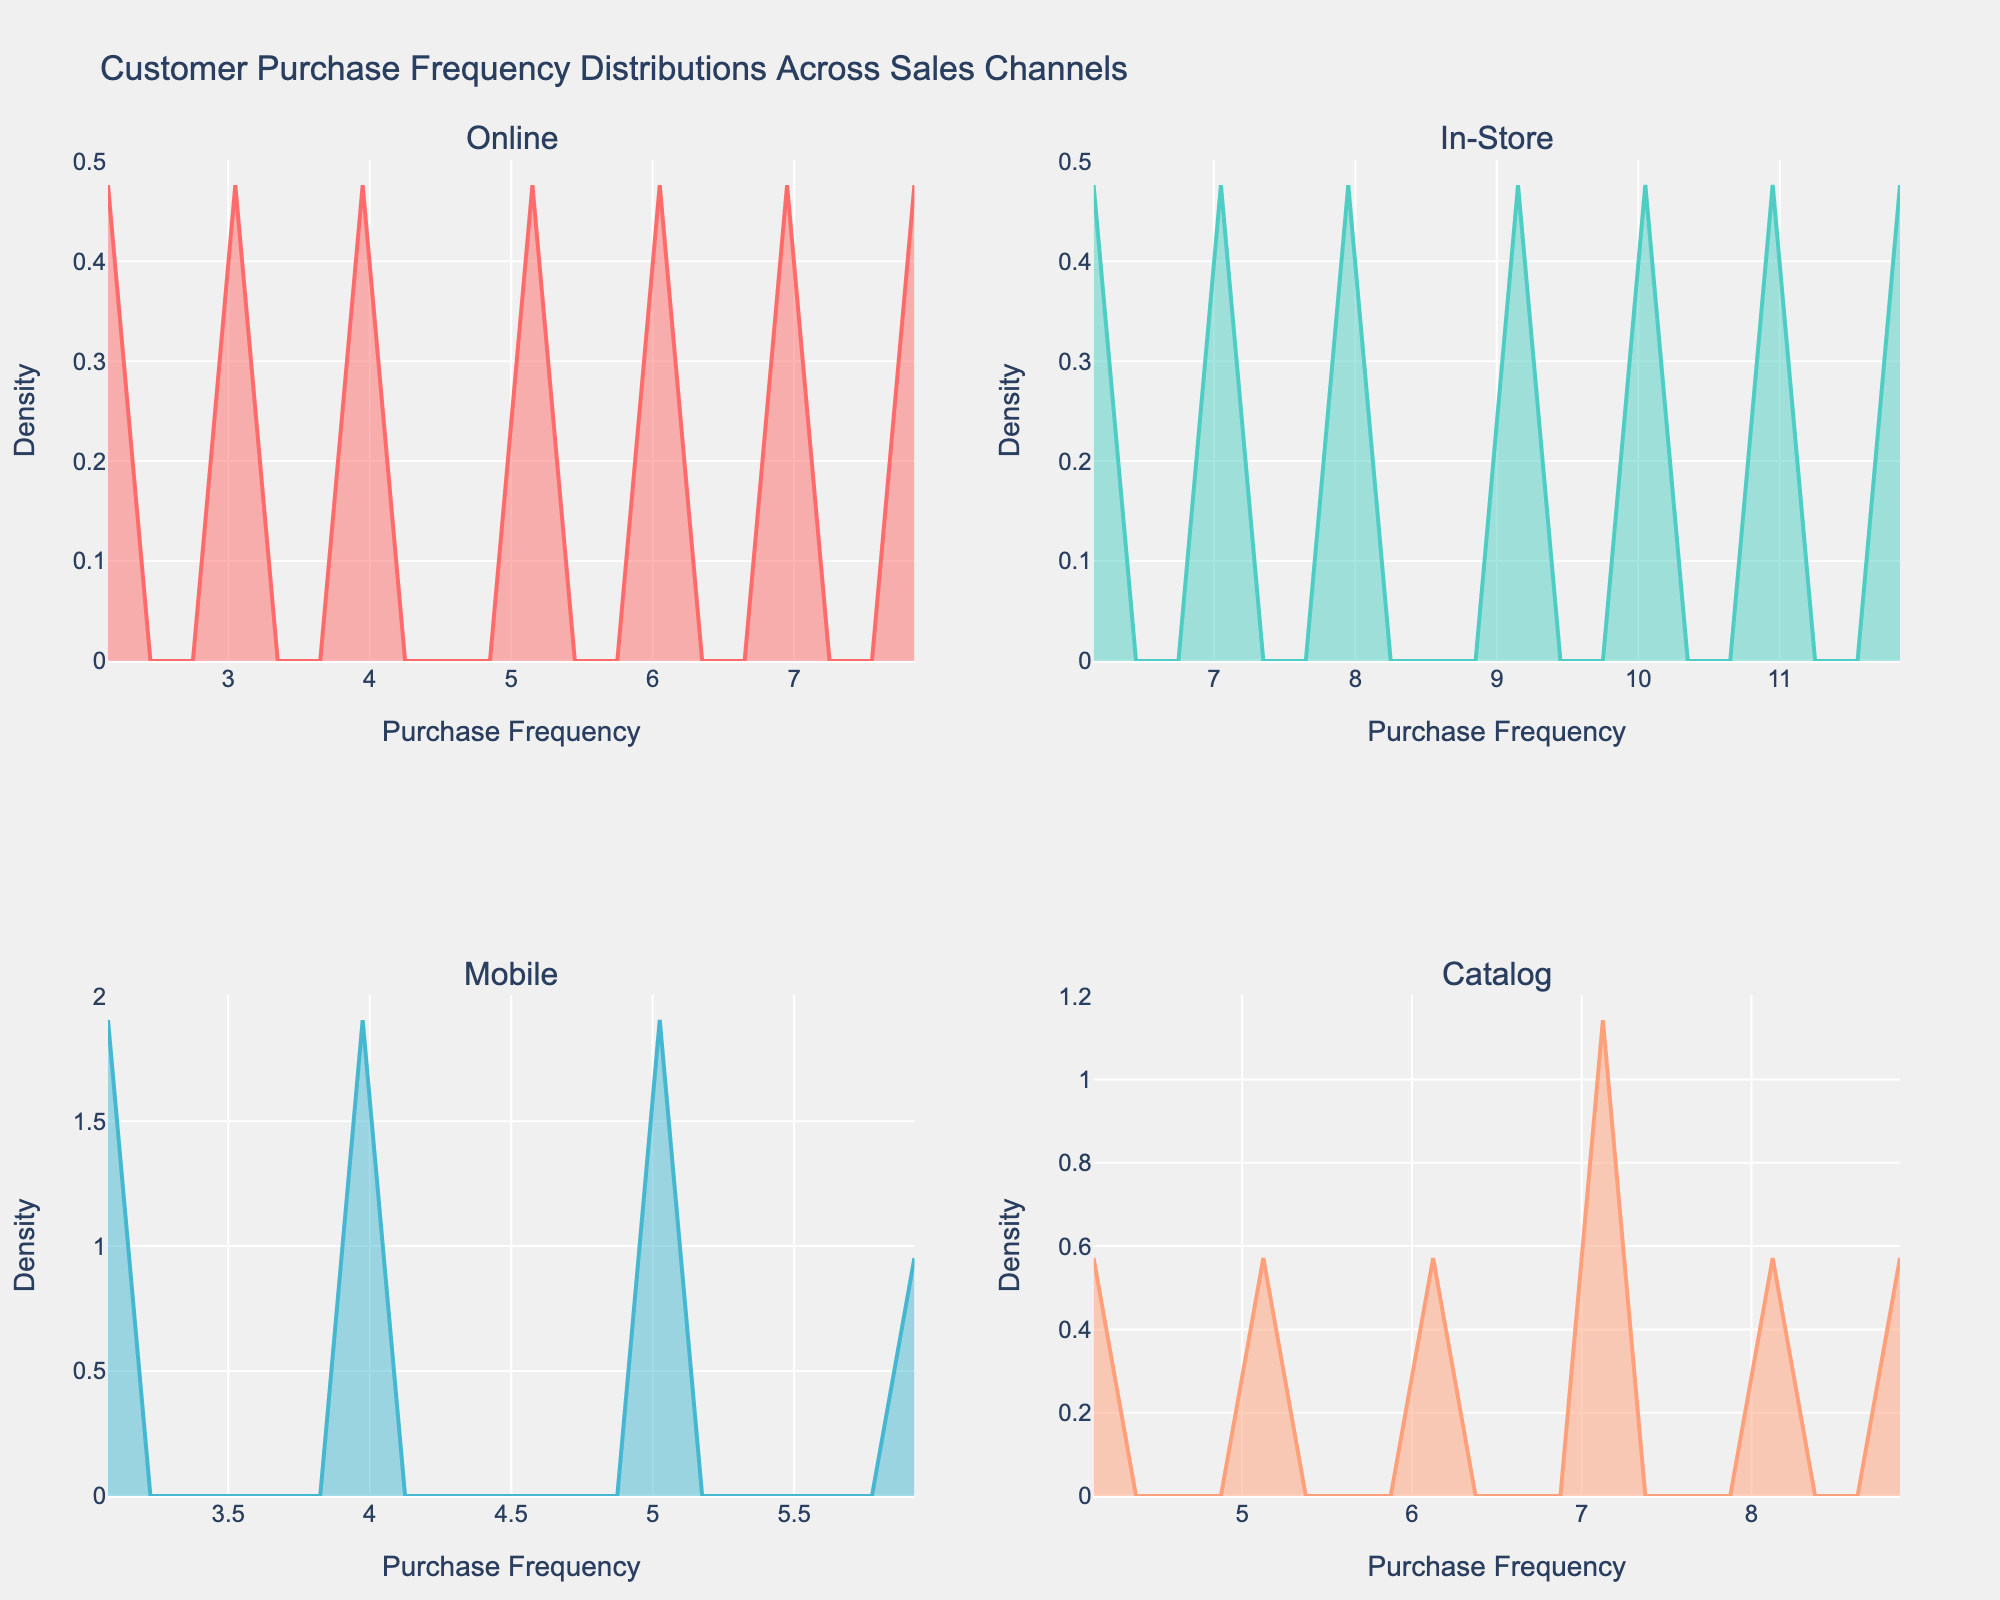What is the title of the figure? The title is located at the top of the figure, providing a summary of what the figure is about.
Answer: Customer Purchase Frequency Distributions Across Sales Channels How many subplots are in the figure? The figure is divided into smaller plots to show the distributions for different sales channels. By counting these smaller plots, we see there are four subplots.
Answer: 4 What is the color used for the Online sales channel density plot? The colors used for each channel can be seen on the specific subplot for Online.
Answer: Red Which sales channel has the highest peak in the density plot? By comparing the peaks of the density plots across the subplots, we can identify the channel with the highest peak.
Answer: In-Store What is the purchase frequency range for the Mobile channel with the highest density? We need to observe the Mobile subplot and identify the range where the density is highest.
Answer: 3 to 5 Which two channels have overlapping density regions? Comparing the density plots visually, we look for channels where the density areas overlap.
Answer: Online and Catalog Is the density distribution for the Catalog channel more spread out or more clustered compared to the Mobile channel? Observing the width of the density plots can indicate whether the distribution is spread out (wider) or clustered (narrower).
Answer: More spread out What is the shape of the density distribution in the In-Store channel? By looking at the In-Store subplot, we can describe the overall shape of its density distribution.
Answer: Bell-shaped Among Online and Mobile channels, which one shows a higher density of low purchase frequencies? By comparing the left side of the density plots for Online and Mobile, we can identify which one has a higher density at lower values.
Answer: Online Is there a channel with a bimodal distribution in its density plot? A bimodal distribution shows two different peaks. By examining each subplot, we can determine if any channel has this characteristic.
Answer: No 